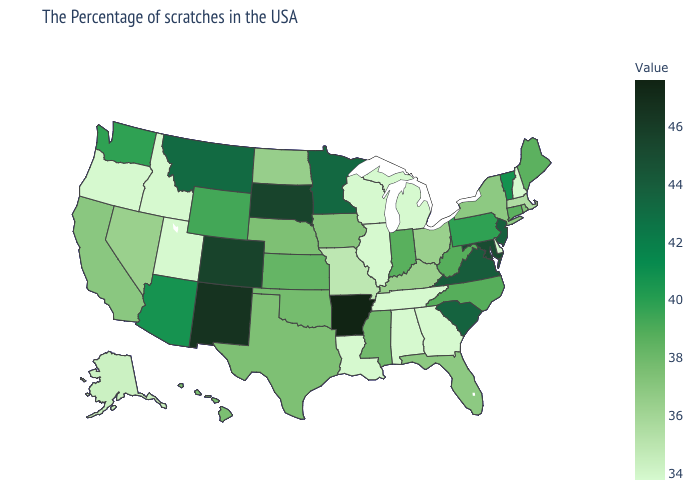Does the map have missing data?
Be succinct. No. Among the states that border Alabama , does Mississippi have the lowest value?
Keep it brief. No. Does Arkansas have the highest value in the USA?
Concise answer only. Yes. Does Texas have a lower value than Minnesota?
Keep it brief. Yes. Does North Dakota have a higher value than New Mexico?
Keep it brief. No. Which states hav the highest value in the Northeast?
Keep it brief. New Jersey. 